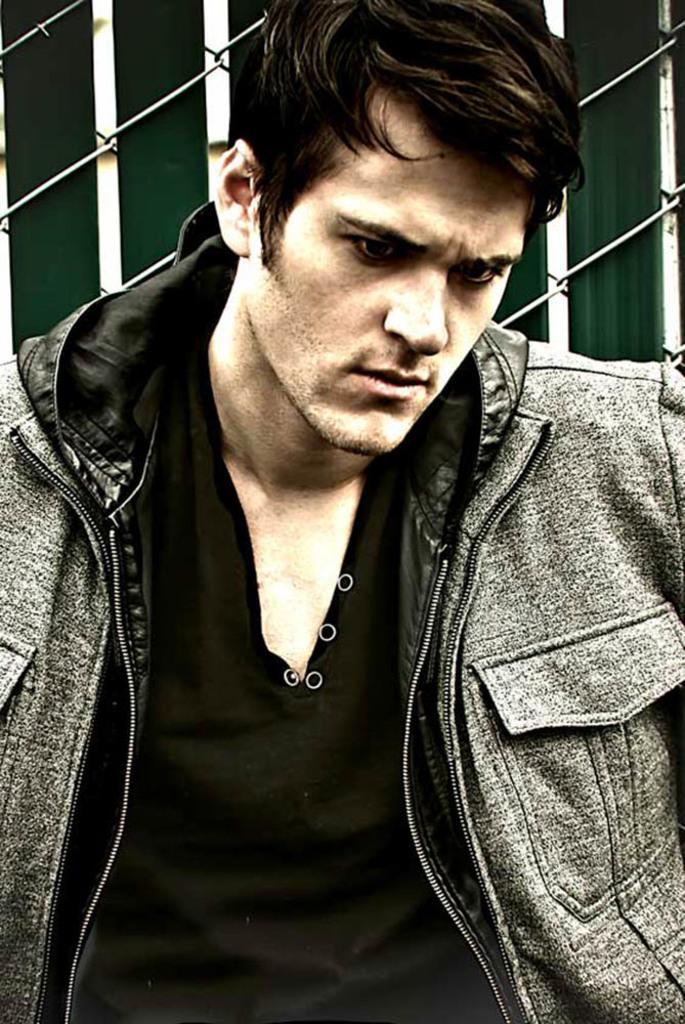Please provide a concise description of this image. In this picture I can see a man, and in the background there are iron wires. 